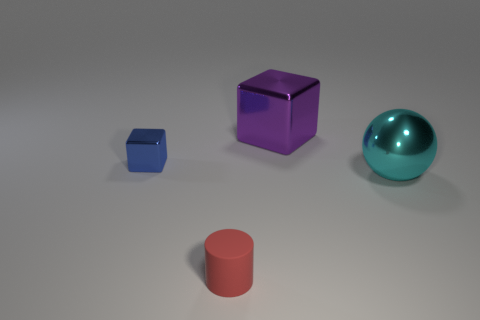Add 3 brown rubber cylinders. How many objects exist? 7 Subtract all cylinders. How many objects are left? 3 Subtract 0 purple spheres. How many objects are left? 4 Subtract all large red metallic cubes. Subtract all blue shiny blocks. How many objects are left? 3 Add 2 big cyan balls. How many big cyan balls are left? 3 Add 1 cyan metallic balls. How many cyan metallic balls exist? 2 